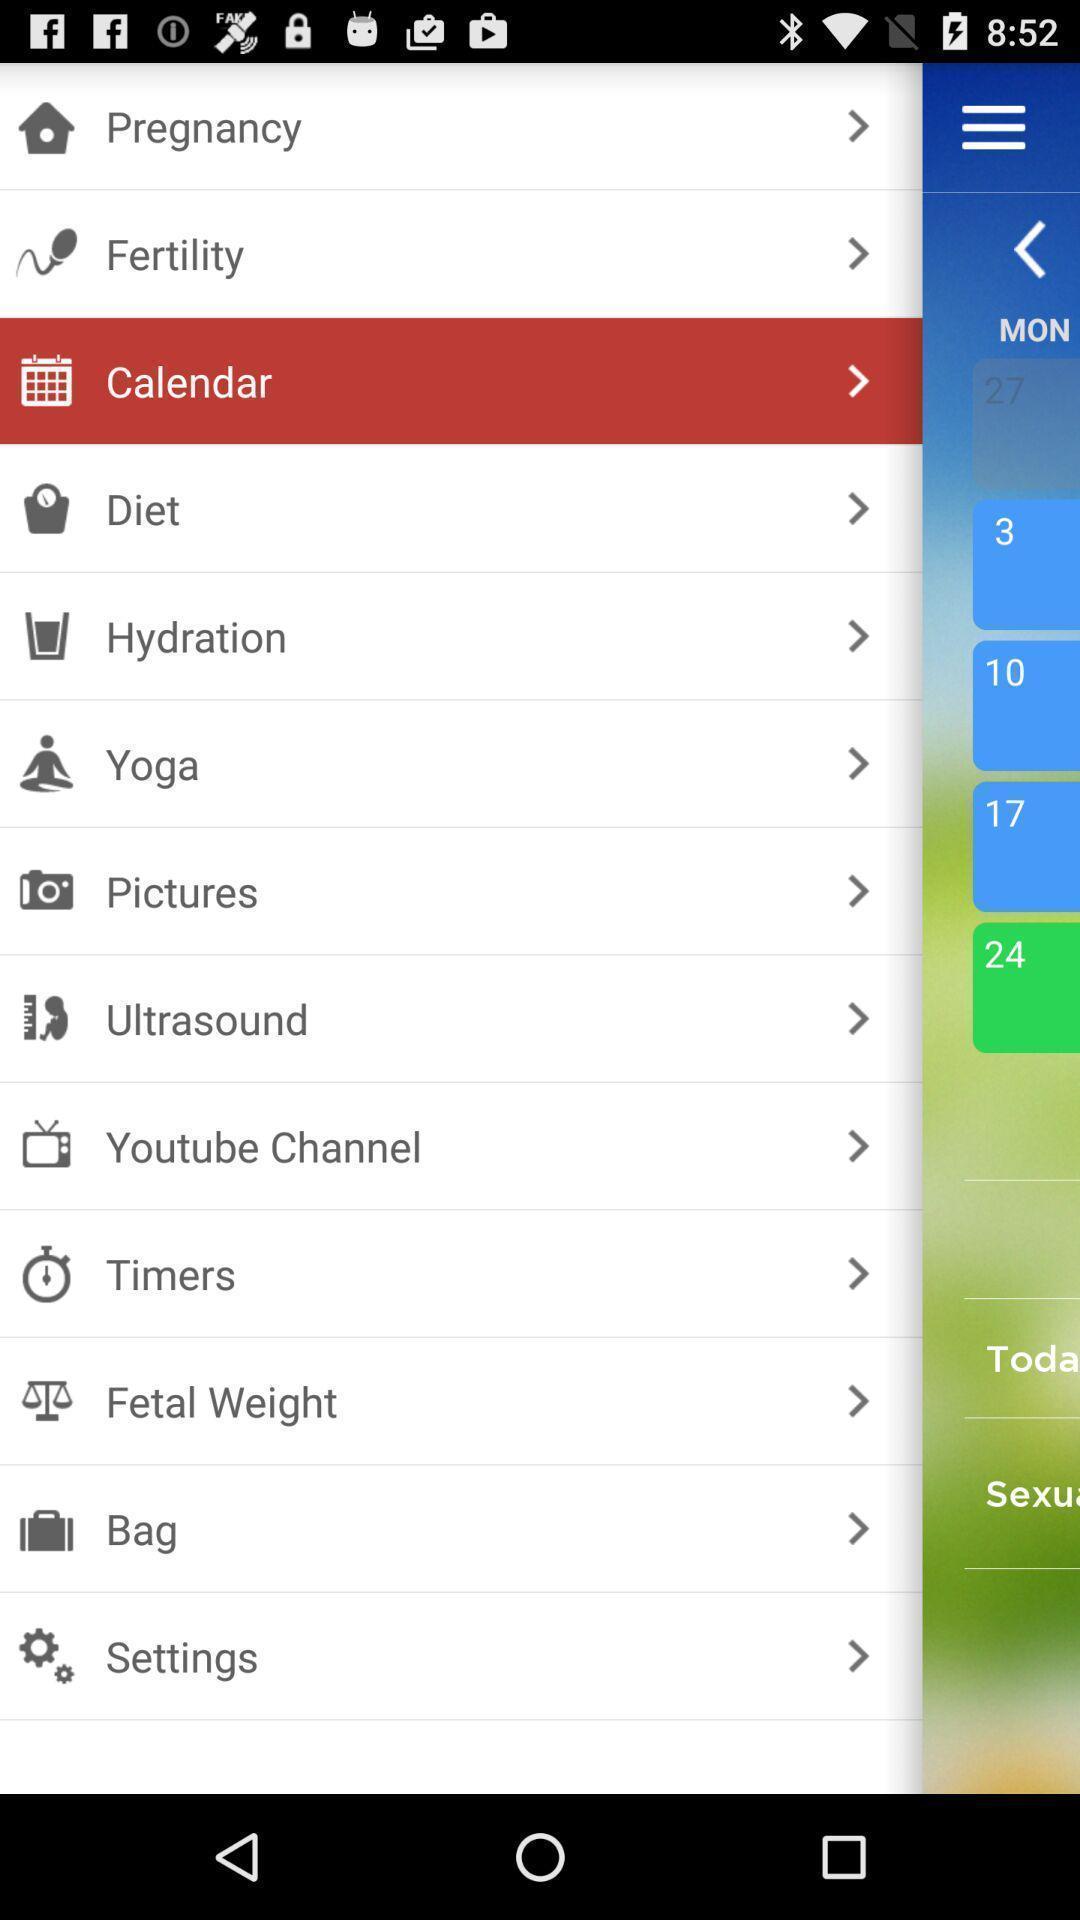Summarize the main components in this picture. Screen shows about pregnancy app. 